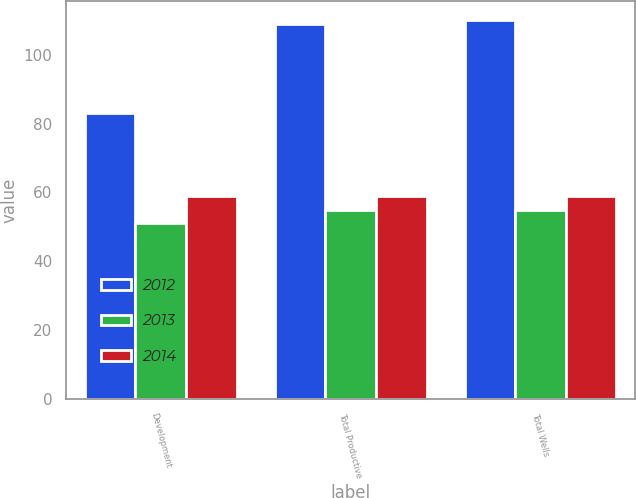Convert chart to OTSL. <chart><loc_0><loc_0><loc_500><loc_500><stacked_bar_chart><ecel><fcel>Development<fcel>Total Productive<fcel>Total Wells<nl><fcel>2012<fcel>83<fcel>109<fcel>110<nl><fcel>2013<fcel>51<fcel>55<fcel>55<nl><fcel>2014<fcel>59<fcel>59<fcel>59<nl></chart> 